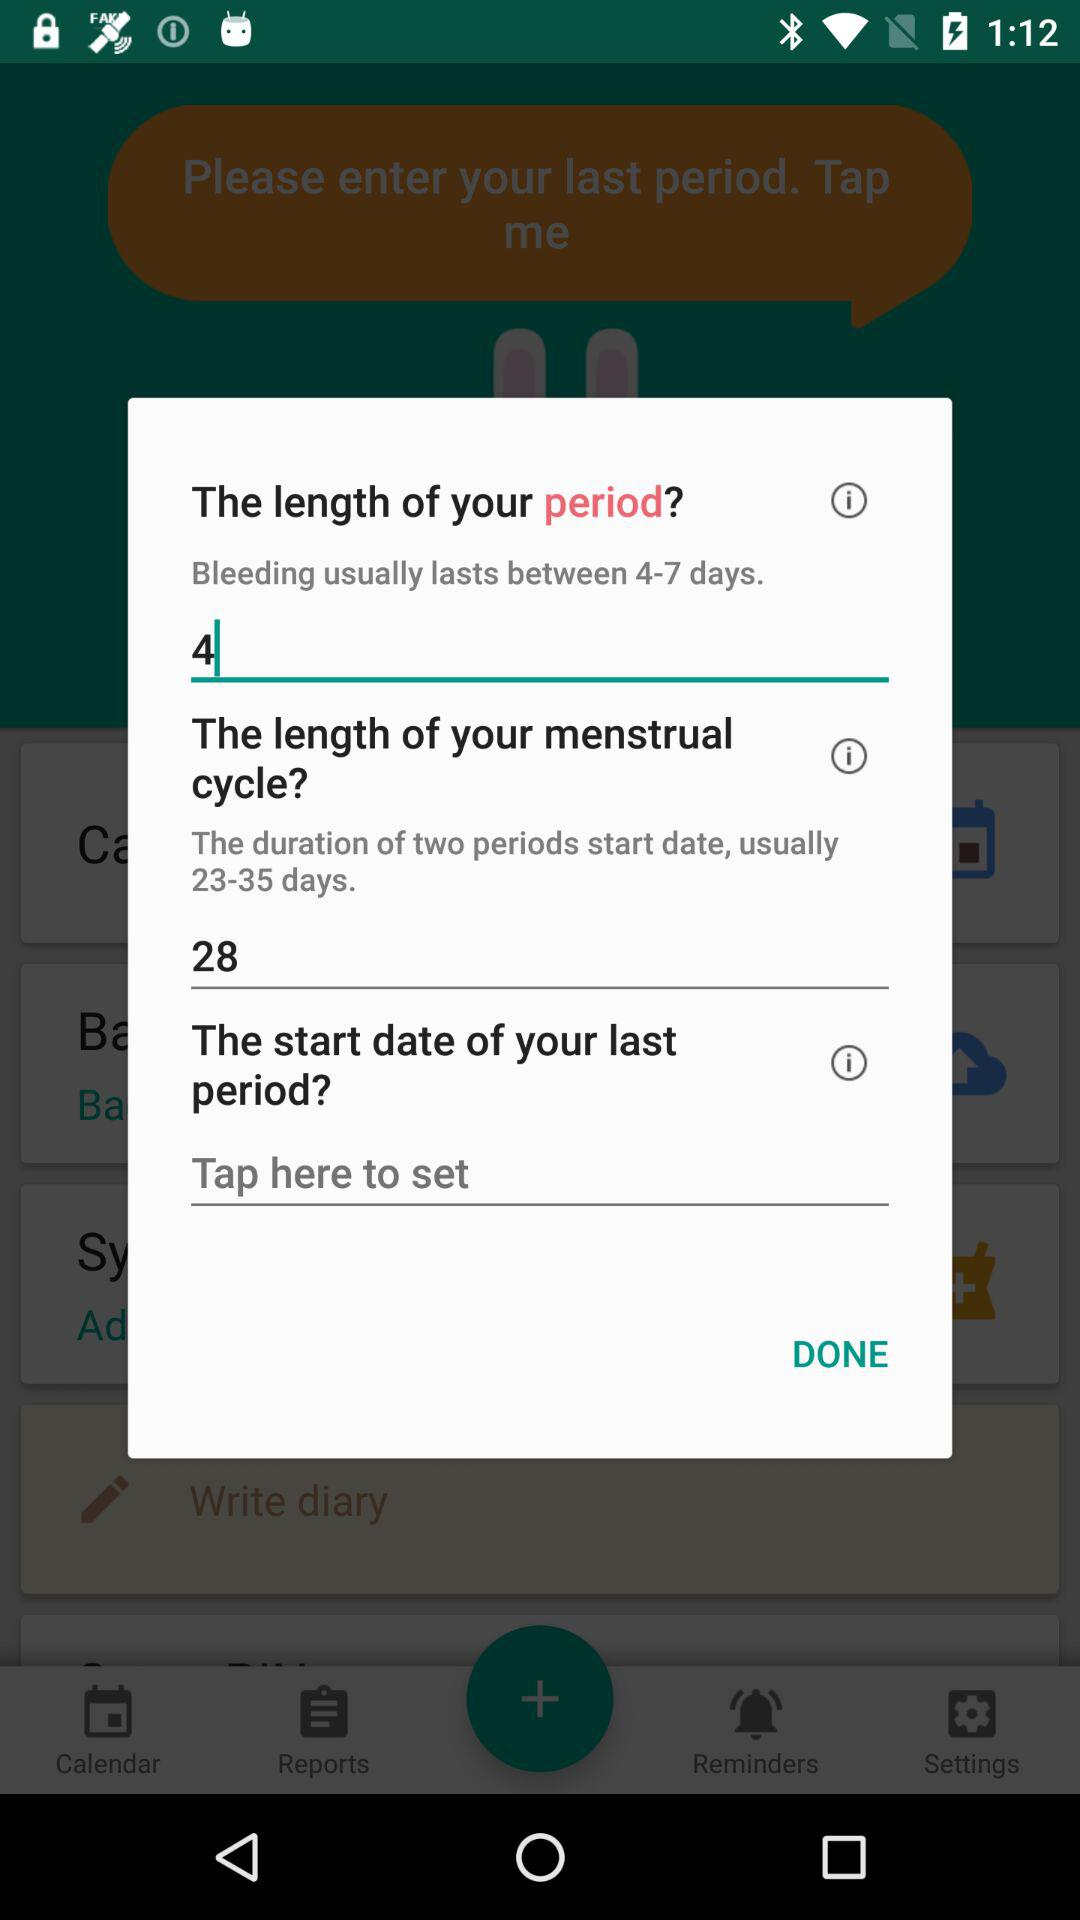What is the length of the menstrual cycle? The length is 28. 